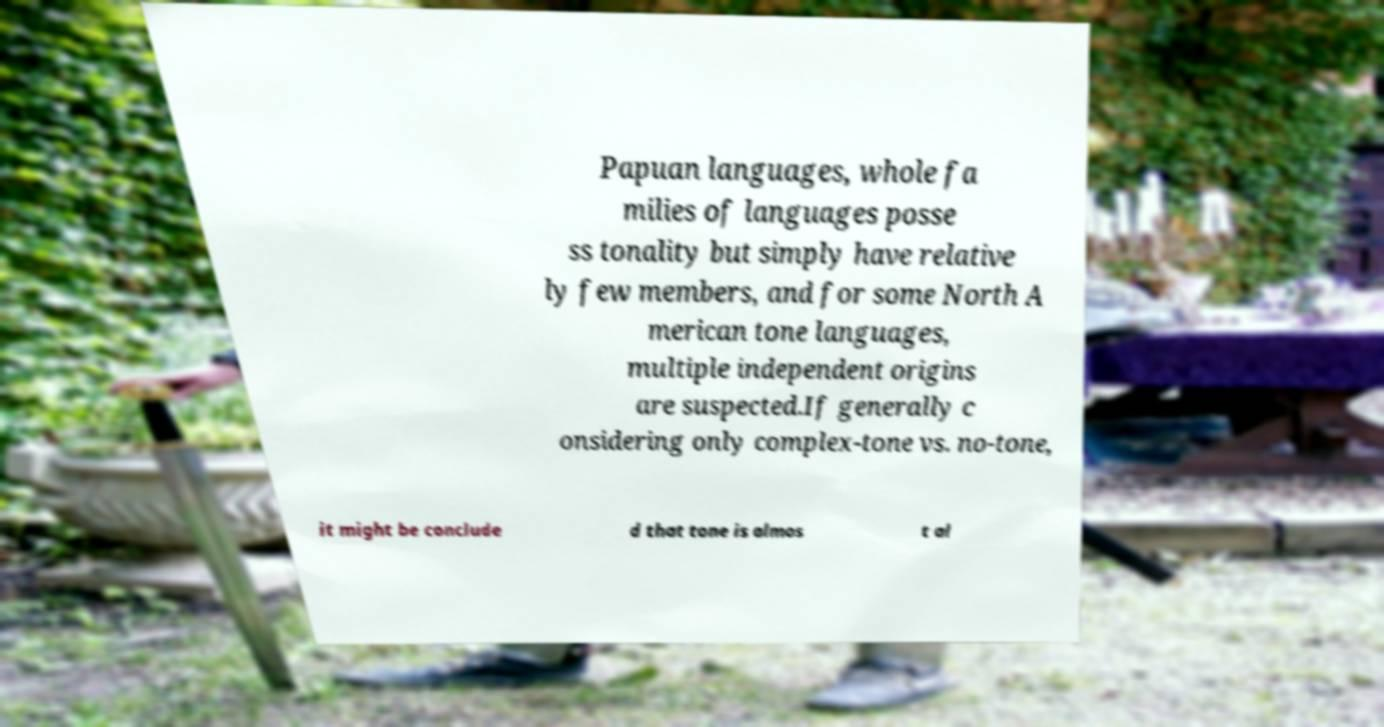For documentation purposes, I need the text within this image transcribed. Could you provide that? Papuan languages, whole fa milies of languages posse ss tonality but simply have relative ly few members, and for some North A merican tone languages, multiple independent origins are suspected.If generally c onsidering only complex-tone vs. no-tone, it might be conclude d that tone is almos t al 